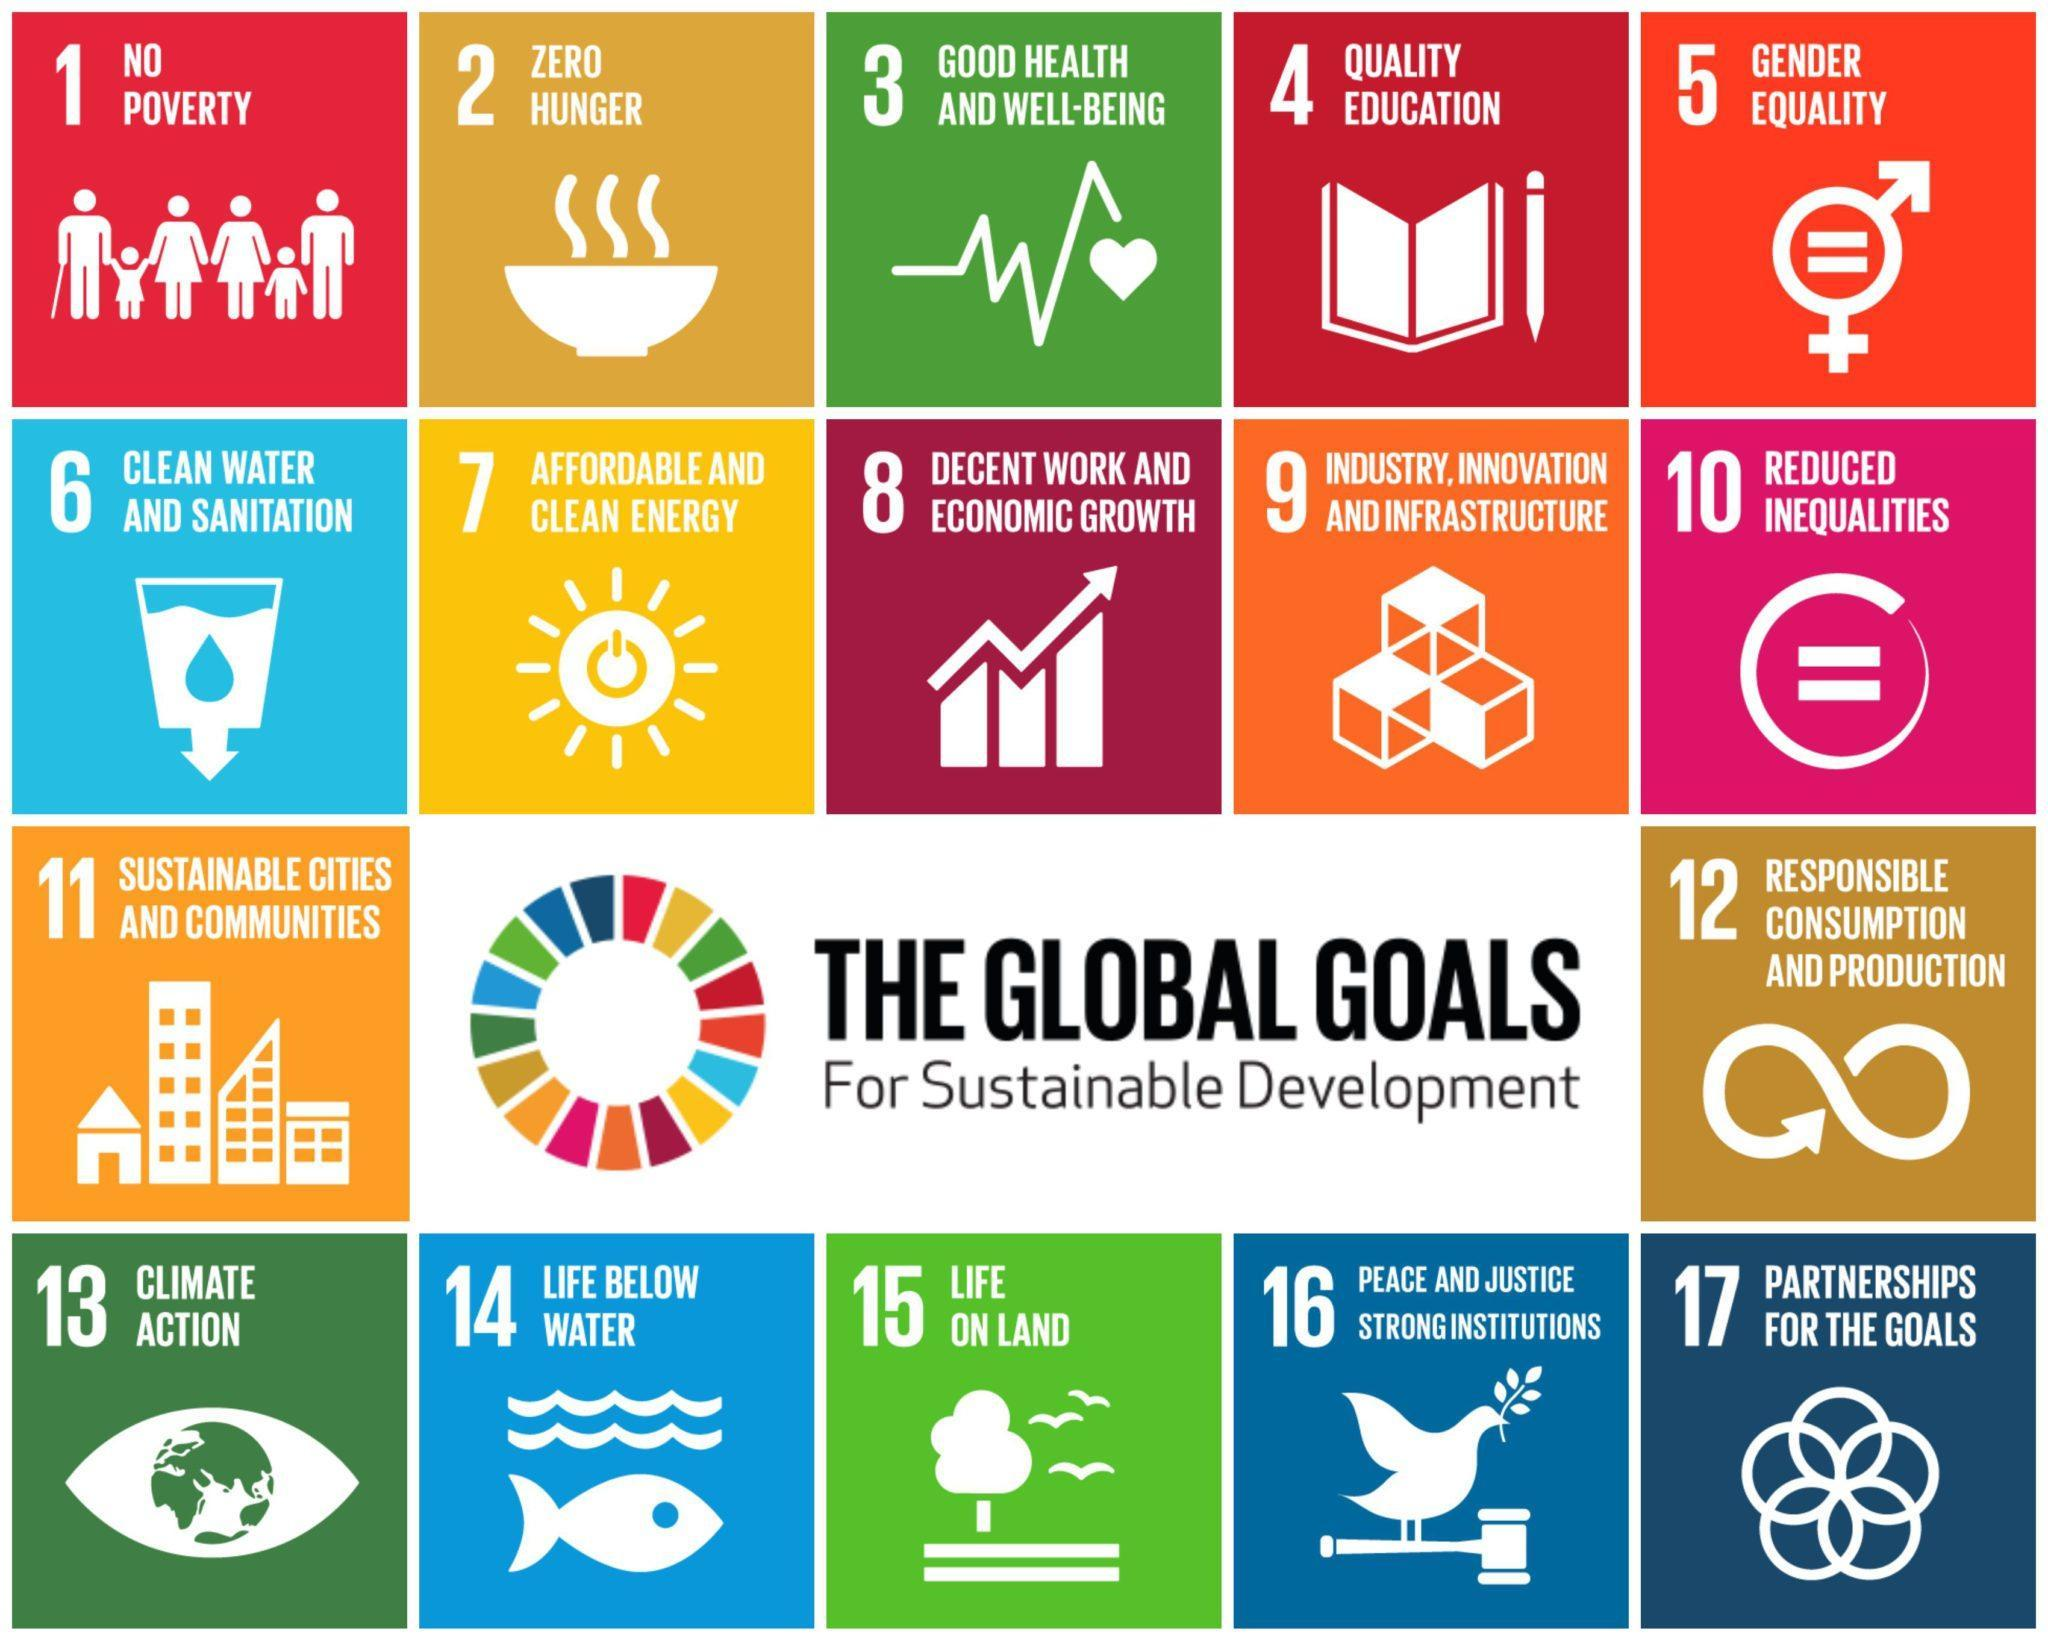what is the goals defined for
Answer the question with a short phrase. sustainable development how many goals are shown in the last row 5 zero hunger is shown by which symbol, bowl or book bowl which are the goals in the 3rd row sustainable cities and communities, responsible consumption and production what goal is denoted by the fish and water symbol life below water 